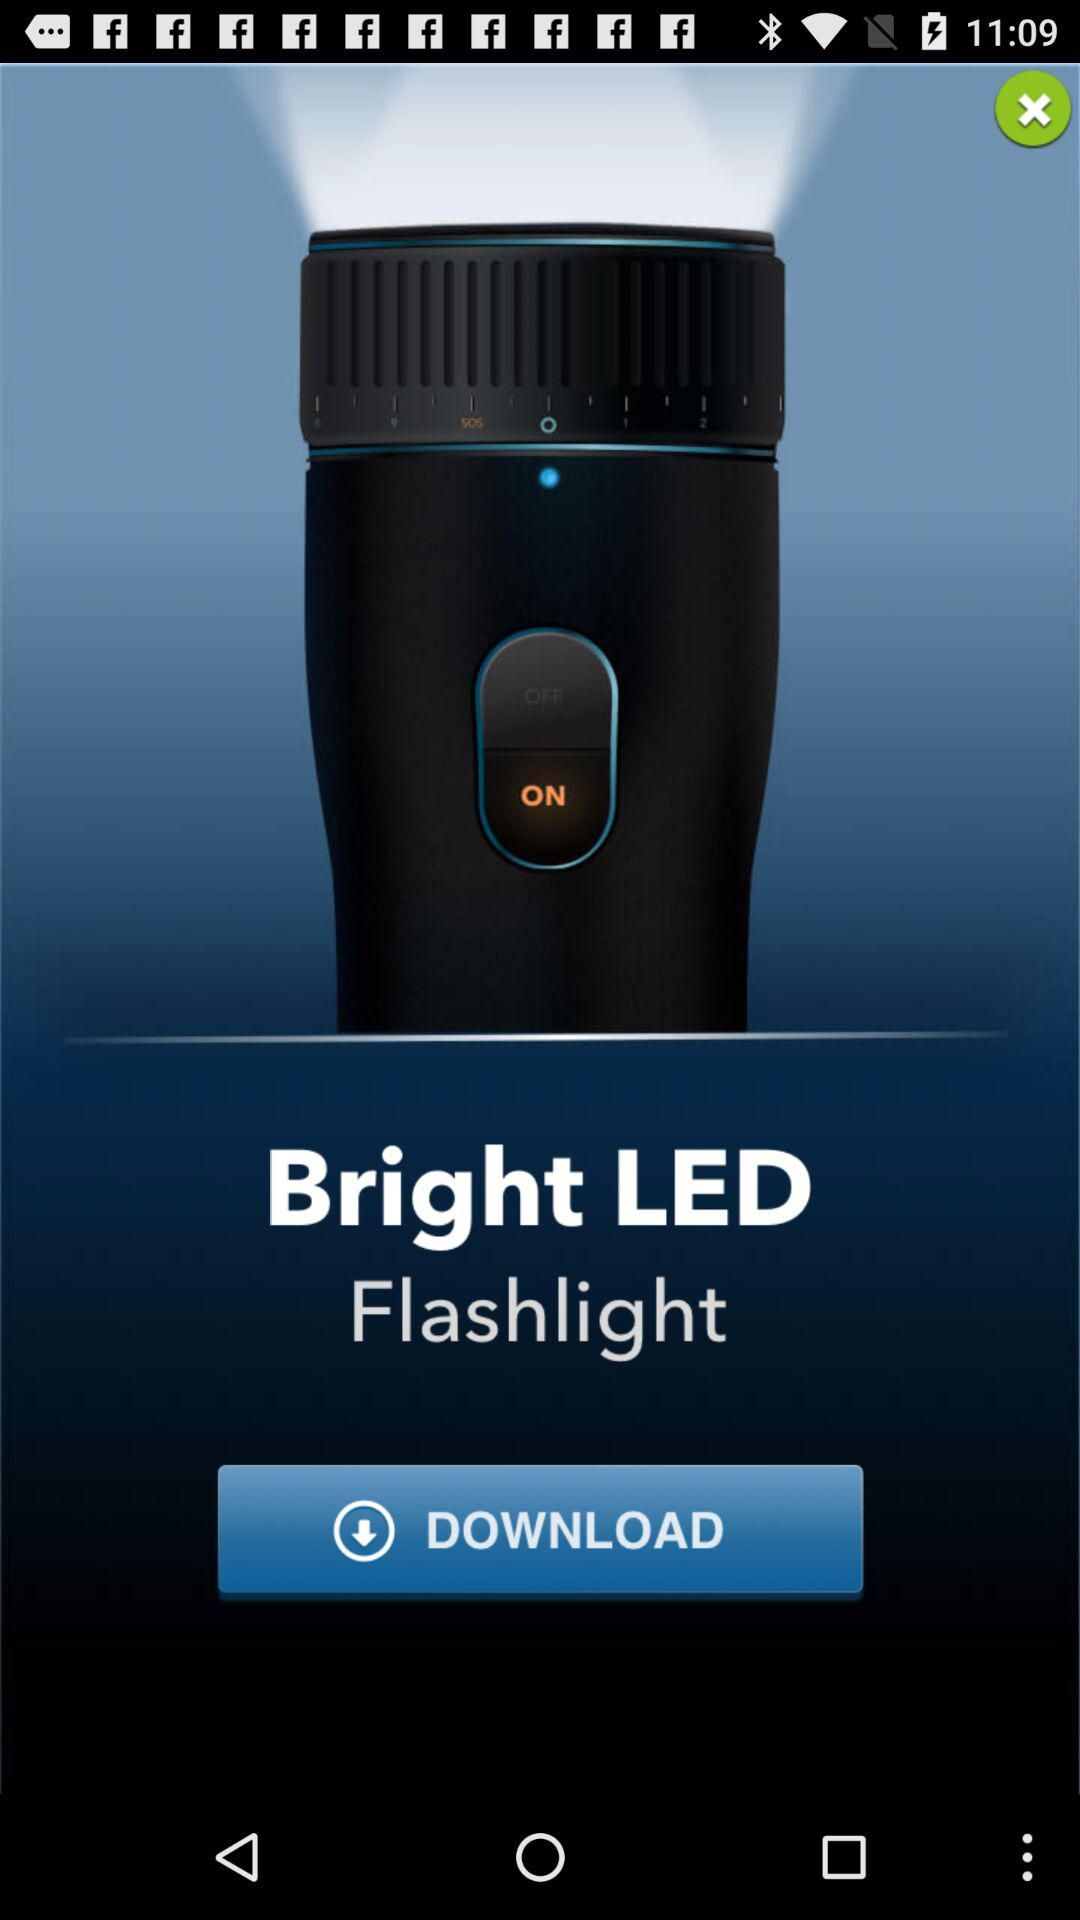What is the name of the application? The application name is "Bright LED Flashlight". 